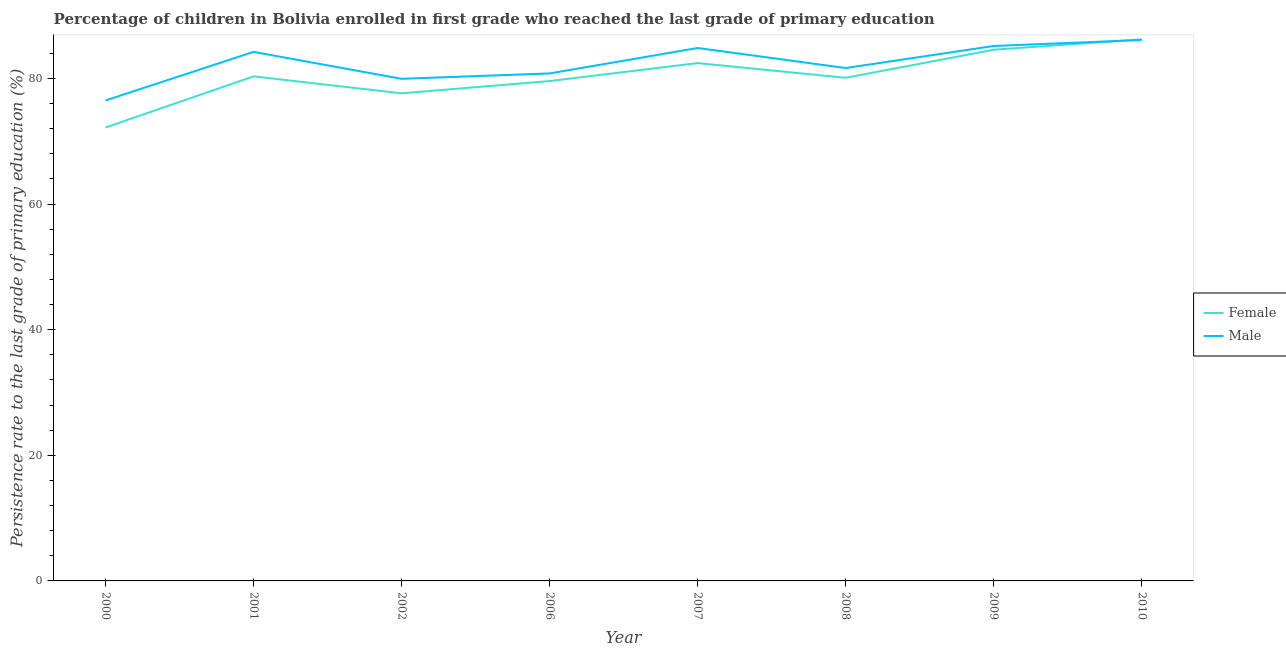How many different coloured lines are there?
Your answer should be compact. 2. What is the persistence rate of female students in 2010?
Your answer should be very brief. 86.24. Across all years, what is the maximum persistence rate of female students?
Offer a very short reply. 86.24. Across all years, what is the minimum persistence rate of female students?
Your answer should be very brief. 72.2. In which year was the persistence rate of male students maximum?
Your answer should be very brief. 2010. In which year was the persistence rate of male students minimum?
Give a very brief answer. 2000. What is the total persistence rate of female students in the graph?
Keep it short and to the point. 643.13. What is the difference between the persistence rate of male students in 2008 and that in 2009?
Offer a very short reply. -3.51. What is the difference between the persistence rate of male students in 2009 and the persistence rate of female students in 2006?
Ensure brevity in your answer.  5.59. What is the average persistence rate of male students per year?
Provide a succinct answer. 82.41. In the year 2001, what is the difference between the persistence rate of male students and persistence rate of female students?
Offer a very short reply. 3.9. What is the ratio of the persistence rate of male students in 2000 to that in 2006?
Your answer should be very brief. 0.95. Is the persistence rate of male students in 2009 less than that in 2010?
Your response must be concise. Yes. Is the difference between the persistence rate of female students in 2006 and 2010 greater than the difference between the persistence rate of male students in 2006 and 2010?
Offer a terse response. No. What is the difference between the highest and the second highest persistence rate of female students?
Your answer should be compact. 1.66. What is the difference between the highest and the lowest persistence rate of female students?
Offer a very short reply. 14.04. Does the persistence rate of male students monotonically increase over the years?
Your answer should be very brief. No. Is the persistence rate of male students strictly less than the persistence rate of female students over the years?
Offer a very short reply. No. How many lines are there?
Provide a short and direct response. 2. What is the difference between two consecutive major ticks on the Y-axis?
Give a very brief answer. 20. Does the graph contain any zero values?
Make the answer very short. No. Does the graph contain grids?
Offer a very short reply. No. Where does the legend appear in the graph?
Provide a short and direct response. Center right. How many legend labels are there?
Your answer should be compact. 2. How are the legend labels stacked?
Provide a short and direct response. Vertical. What is the title of the graph?
Give a very brief answer. Percentage of children in Bolivia enrolled in first grade who reached the last grade of primary education. Does "Rural" appear as one of the legend labels in the graph?
Keep it short and to the point. No. What is the label or title of the Y-axis?
Ensure brevity in your answer.  Persistence rate to the last grade of primary education (%). What is the Persistence rate to the last grade of primary education (%) in Female in 2000?
Make the answer very short. 72.2. What is the Persistence rate to the last grade of primary education (%) of Male in 2000?
Ensure brevity in your answer.  76.5. What is the Persistence rate to the last grade of primary education (%) of Female in 2001?
Your answer should be compact. 80.34. What is the Persistence rate to the last grade of primary education (%) of Male in 2001?
Give a very brief answer. 84.23. What is the Persistence rate to the last grade of primary education (%) in Female in 2002?
Provide a short and direct response. 77.64. What is the Persistence rate to the last grade of primary education (%) in Male in 2002?
Provide a short and direct response. 79.95. What is the Persistence rate to the last grade of primary education (%) of Female in 2006?
Keep it short and to the point. 79.59. What is the Persistence rate to the last grade of primary education (%) in Male in 2006?
Your answer should be very brief. 80.8. What is the Persistence rate to the last grade of primary education (%) of Female in 2007?
Your answer should be compact. 82.45. What is the Persistence rate to the last grade of primary education (%) of Male in 2007?
Your answer should be compact. 84.85. What is the Persistence rate to the last grade of primary education (%) in Female in 2008?
Provide a succinct answer. 80.11. What is the Persistence rate to the last grade of primary education (%) in Male in 2008?
Provide a short and direct response. 81.66. What is the Persistence rate to the last grade of primary education (%) in Female in 2009?
Make the answer very short. 84.58. What is the Persistence rate to the last grade of primary education (%) in Male in 2009?
Your answer should be compact. 85.17. What is the Persistence rate to the last grade of primary education (%) in Female in 2010?
Your answer should be compact. 86.24. What is the Persistence rate to the last grade of primary education (%) of Male in 2010?
Ensure brevity in your answer.  86.13. Across all years, what is the maximum Persistence rate to the last grade of primary education (%) of Female?
Make the answer very short. 86.24. Across all years, what is the maximum Persistence rate to the last grade of primary education (%) of Male?
Your answer should be very brief. 86.13. Across all years, what is the minimum Persistence rate to the last grade of primary education (%) of Female?
Your answer should be compact. 72.2. Across all years, what is the minimum Persistence rate to the last grade of primary education (%) in Male?
Ensure brevity in your answer.  76.5. What is the total Persistence rate to the last grade of primary education (%) of Female in the graph?
Provide a short and direct response. 643.13. What is the total Persistence rate to the last grade of primary education (%) of Male in the graph?
Provide a short and direct response. 659.3. What is the difference between the Persistence rate to the last grade of primary education (%) of Female in 2000 and that in 2001?
Your answer should be compact. -8.14. What is the difference between the Persistence rate to the last grade of primary education (%) in Male in 2000 and that in 2001?
Provide a succinct answer. -7.73. What is the difference between the Persistence rate to the last grade of primary education (%) of Female in 2000 and that in 2002?
Offer a terse response. -5.44. What is the difference between the Persistence rate to the last grade of primary education (%) in Male in 2000 and that in 2002?
Provide a succinct answer. -3.45. What is the difference between the Persistence rate to the last grade of primary education (%) in Female in 2000 and that in 2006?
Ensure brevity in your answer.  -7.39. What is the difference between the Persistence rate to the last grade of primary education (%) of Male in 2000 and that in 2006?
Your answer should be compact. -4.3. What is the difference between the Persistence rate to the last grade of primary education (%) of Female in 2000 and that in 2007?
Ensure brevity in your answer.  -10.25. What is the difference between the Persistence rate to the last grade of primary education (%) in Male in 2000 and that in 2007?
Provide a short and direct response. -8.35. What is the difference between the Persistence rate to the last grade of primary education (%) of Female in 2000 and that in 2008?
Give a very brief answer. -7.91. What is the difference between the Persistence rate to the last grade of primary education (%) in Male in 2000 and that in 2008?
Offer a terse response. -5.16. What is the difference between the Persistence rate to the last grade of primary education (%) in Female in 2000 and that in 2009?
Offer a very short reply. -12.38. What is the difference between the Persistence rate to the last grade of primary education (%) in Male in 2000 and that in 2009?
Provide a short and direct response. -8.67. What is the difference between the Persistence rate to the last grade of primary education (%) of Female in 2000 and that in 2010?
Keep it short and to the point. -14.04. What is the difference between the Persistence rate to the last grade of primary education (%) in Male in 2000 and that in 2010?
Offer a terse response. -9.63. What is the difference between the Persistence rate to the last grade of primary education (%) of Female in 2001 and that in 2002?
Give a very brief answer. 2.7. What is the difference between the Persistence rate to the last grade of primary education (%) of Male in 2001 and that in 2002?
Offer a very short reply. 4.29. What is the difference between the Persistence rate to the last grade of primary education (%) in Female in 2001 and that in 2006?
Provide a short and direct response. 0.75. What is the difference between the Persistence rate to the last grade of primary education (%) in Male in 2001 and that in 2006?
Ensure brevity in your answer.  3.43. What is the difference between the Persistence rate to the last grade of primary education (%) of Female in 2001 and that in 2007?
Ensure brevity in your answer.  -2.11. What is the difference between the Persistence rate to the last grade of primary education (%) of Male in 2001 and that in 2007?
Keep it short and to the point. -0.62. What is the difference between the Persistence rate to the last grade of primary education (%) in Female in 2001 and that in 2008?
Your response must be concise. 0.23. What is the difference between the Persistence rate to the last grade of primary education (%) of Male in 2001 and that in 2008?
Provide a short and direct response. 2.57. What is the difference between the Persistence rate to the last grade of primary education (%) in Female in 2001 and that in 2009?
Give a very brief answer. -4.24. What is the difference between the Persistence rate to the last grade of primary education (%) in Male in 2001 and that in 2009?
Provide a short and direct response. -0.94. What is the difference between the Persistence rate to the last grade of primary education (%) in Female in 2001 and that in 2010?
Offer a very short reply. -5.9. What is the difference between the Persistence rate to the last grade of primary education (%) in Male in 2001 and that in 2010?
Offer a very short reply. -1.9. What is the difference between the Persistence rate to the last grade of primary education (%) in Female in 2002 and that in 2006?
Keep it short and to the point. -1.95. What is the difference between the Persistence rate to the last grade of primary education (%) of Male in 2002 and that in 2006?
Ensure brevity in your answer.  -0.85. What is the difference between the Persistence rate to the last grade of primary education (%) of Female in 2002 and that in 2007?
Your answer should be compact. -4.81. What is the difference between the Persistence rate to the last grade of primary education (%) of Male in 2002 and that in 2007?
Keep it short and to the point. -4.91. What is the difference between the Persistence rate to the last grade of primary education (%) of Female in 2002 and that in 2008?
Your answer should be very brief. -2.47. What is the difference between the Persistence rate to the last grade of primary education (%) in Male in 2002 and that in 2008?
Offer a terse response. -1.72. What is the difference between the Persistence rate to the last grade of primary education (%) of Female in 2002 and that in 2009?
Your response must be concise. -6.94. What is the difference between the Persistence rate to the last grade of primary education (%) of Male in 2002 and that in 2009?
Your response must be concise. -5.23. What is the difference between the Persistence rate to the last grade of primary education (%) of Female in 2002 and that in 2010?
Offer a terse response. -8.6. What is the difference between the Persistence rate to the last grade of primary education (%) in Male in 2002 and that in 2010?
Provide a succinct answer. -6.18. What is the difference between the Persistence rate to the last grade of primary education (%) in Female in 2006 and that in 2007?
Make the answer very short. -2.86. What is the difference between the Persistence rate to the last grade of primary education (%) of Male in 2006 and that in 2007?
Keep it short and to the point. -4.05. What is the difference between the Persistence rate to the last grade of primary education (%) of Female in 2006 and that in 2008?
Offer a very short reply. -0.52. What is the difference between the Persistence rate to the last grade of primary education (%) in Male in 2006 and that in 2008?
Offer a terse response. -0.86. What is the difference between the Persistence rate to the last grade of primary education (%) in Female in 2006 and that in 2009?
Provide a short and direct response. -4.99. What is the difference between the Persistence rate to the last grade of primary education (%) in Male in 2006 and that in 2009?
Ensure brevity in your answer.  -4.37. What is the difference between the Persistence rate to the last grade of primary education (%) of Female in 2006 and that in 2010?
Your answer should be very brief. -6.65. What is the difference between the Persistence rate to the last grade of primary education (%) of Male in 2006 and that in 2010?
Keep it short and to the point. -5.33. What is the difference between the Persistence rate to the last grade of primary education (%) of Female in 2007 and that in 2008?
Offer a terse response. 2.34. What is the difference between the Persistence rate to the last grade of primary education (%) in Male in 2007 and that in 2008?
Provide a succinct answer. 3.19. What is the difference between the Persistence rate to the last grade of primary education (%) in Female in 2007 and that in 2009?
Ensure brevity in your answer.  -2.13. What is the difference between the Persistence rate to the last grade of primary education (%) of Male in 2007 and that in 2009?
Offer a terse response. -0.32. What is the difference between the Persistence rate to the last grade of primary education (%) in Female in 2007 and that in 2010?
Offer a very short reply. -3.79. What is the difference between the Persistence rate to the last grade of primary education (%) in Male in 2007 and that in 2010?
Your answer should be very brief. -1.28. What is the difference between the Persistence rate to the last grade of primary education (%) of Female in 2008 and that in 2009?
Ensure brevity in your answer.  -4.47. What is the difference between the Persistence rate to the last grade of primary education (%) of Male in 2008 and that in 2009?
Give a very brief answer. -3.51. What is the difference between the Persistence rate to the last grade of primary education (%) in Female in 2008 and that in 2010?
Make the answer very short. -6.13. What is the difference between the Persistence rate to the last grade of primary education (%) of Male in 2008 and that in 2010?
Provide a short and direct response. -4.47. What is the difference between the Persistence rate to the last grade of primary education (%) of Female in 2009 and that in 2010?
Your answer should be very brief. -1.66. What is the difference between the Persistence rate to the last grade of primary education (%) in Male in 2009 and that in 2010?
Your response must be concise. -0.96. What is the difference between the Persistence rate to the last grade of primary education (%) of Female in 2000 and the Persistence rate to the last grade of primary education (%) of Male in 2001?
Make the answer very short. -12.04. What is the difference between the Persistence rate to the last grade of primary education (%) in Female in 2000 and the Persistence rate to the last grade of primary education (%) in Male in 2002?
Give a very brief answer. -7.75. What is the difference between the Persistence rate to the last grade of primary education (%) in Female in 2000 and the Persistence rate to the last grade of primary education (%) in Male in 2006?
Offer a terse response. -8.61. What is the difference between the Persistence rate to the last grade of primary education (%) of Female in 2000 and the Persistence rate to the last grade of primary education (%) of Male in 2007?
Your response must be concise. -12.66. What is the difference between the Persistence rate to the last grade of primary education (%) of Female in 2000 and the Persistence rate to the last grade of primary education (%) of Male in 2008?
Make the answer very short. -9.47. What is the difference between the Persistence rate to the last grade of primary education (%) in Female in 2000 and the Persistence rate to the last grade of primary education (%) in Male in 2009?
Your answer should be compact. -12.98. What is the difference between the Persistence rate to the last grade of primary education (%) in Female in 2000 and the Persistence rate to the last grade of primary education (%) in Male in 2010?
Offer a terse response. -13.93. What is the difference between the Persistence rate to the last grade of primary education (%) of Female in 2001 and the Persistence rate to the last grade of primary education (%) of Male in 2002?
Your answer should be compact. 0.39. What is the difference between the Persistence rate to the last grade of primary education (%) in Female in 2001 and the Persistence rate to the last grade of primary education (%) in Male in 2006?
Your answer should be compact. -0.47. What is the difference between the Persistence rate to the last grade of primary education (%) in Female in 2001 and the Persistence rate to the last grade of primary education (%) in Male in 2007?
Provide a succinct answer. -4.52. What is the difference between the Persistence rate to the last grade of primary education (%) in Female in 2001 and the Persistence rate to the last grade of primary education (%) in Male in 2008?
Keep it short and to the point. -1.33. What is the difference between the Persistence rate to the last grade of primary education (%) in Female in 2001 and the Persistence rate to the last grade of primary education (%) in Male in 2009?
Keep it short and to the point. -4.84. What is the difference between the Persistence rate to the last grade of primary education (%) of Female in 2001 and the Persistence rate to the last grade of primary education (%) of Male in 2010?
Your answer should be very brief. -5.79. What is the difference between the Persistence rate to the last grade of primary education (%) in Female in 2002 and the Persistence rate to the last grade of primary education (%) in Male in 2006?
Your answer should be compact. -3.17. What is the difference between the Persistence rate to the last grade of primary education (%) in Female in 2002 and the Persistence rate to the last grade of primary education (%) in Male in 2007?
Provide a succinct answer. -7.22. What is the difference between the Persistence rate to the last grade of primary education (%) in Female in 2002 and the Persistence rate to the last grade of primary education (%) in Male in 2008?
Provide a short and direct response. -4.03. What is the difference between the Persistence rate to the last grade of primary education (%) of Female in 2002 and the Persistence rate to the last grade of primary education (%) of Male in 2009?
Offer a terse response. -7.54. What is the difference between the Persistence rate to the last grade of primary education (%) of Female in 2002 and the Persistence rate to the last grade of primary education (%) of Male in 2010?
Your answer should be compact. -8.49. What is the difference between the Persistence rate to the last grade of primary education (%) of Female in 2006 and the Persistence rate to the last grade of primary education (%) of Male in 2007?
Offer a very short reply. -5.27. What is the difference between the Persistence rate to the last grade of primary education (%) in Female in 2006 and the Persistence rate to the last grade of primary education (%) in Male in 2008?
Provide a succinct answer. -2.08. What is the difference between the Persistence rate to the last grade of primary education (%) in Female in 2006 and the Persistence rate to the last grade of primary education (%) in Male in 2009?
Give a very brief answer. -5.59. What is the difference between the Persistence rate to the last grade of primary education (%) in Female in 2006 and the Persistence rate to the last grade of primary education (%) in Male in 2010?
Give a very brief answer. -6.54. What is the difference between the Persistence rate to the last grade of primary education (%) of Female in 2007 and the Persistence rate to the last grade of primary education (%) of Male in 2008?
Provide a succinct answer. 0.79. What is the difference between the Persistence rate to the last grade of primary education (%) of Female in 2007 and the Persistence rate to the last grade of primary education (%) of Male in 2009?
Ensure brevity in your answer.  -2.72. What is the difference between the Persistence rate to the last grade of primary education (%) of Female in 2007 and the Persistence rate to the last grade of primary education (%) of Male in 2010?
Offer a terse response. -3.68. What is the difference between the Persistence rate to the last grade of primary education (%) in Female in 2008 and the Persistence rate to the last grade of primary education (%) in Male in 2009?
Provide a short and direct response. -5.07. What is the difference between the Persistence rate to the last grade of primary education (%) in Female in 2008 and the Persistence rate to the last grade of primary education (%) in Male in 2010?
Offer a terse response. -6.02. What is the difference between the Persistence rate to the last grade of primary education (%) in Female in 2009 and the Persistence rate to the last grade of primary education (%) in Male in 2010?
Offer a very short reply. -1.55. What is the average Persistence rate to the last grade of primary education (%) of Female per year?
Your response must be concise. 80.39. What is the average Persistence rate to the last grade of primary education (%) of Male per year?
Your response must be concise. 82.41. In the year 2000, what is the difference between the Persistence rate to the last grade of primary education (%) of Female and Persistence rate to the last grade of primary education (%) of Male?
Offer a very short reply. -4.3. In the year 2001, what is the difference between the Persistence rate to the last grade of primary education (%) of Female and Persistence rate to the last grade of primary education (%) of Male?
Your answer should be compact. -3.9. In the year 2002, what is the difference between the Persistence rate to the last grade of primary education (%) in Female and Persistence rate to the last grade of primary education (%) in Male?
Offer a very short reply. -2.31. In the year 2006, what is the difference between the Persistence rate to the last grade of primary education (%) of Female and Persistence rate to the last grade of primary education (%) of Male?
Offer a very short reply. -1.21. In the year 2007, what is the difference between the Persistence rate to the last grade of primary education (%) in Female and Persistence rate to the last grade of primary education (%) in Male?
Your response must be concise. -2.4. In the year 2008, what is the difference between the Persistence rate to the last grade of primary education (%) of Female and Persistence rate to the last grade of primary education (%) of Male?
Give a very brief answer. -1.56. In the year 2009, what is the difference between the Persistence rate to the last grade of primary education (%) of Female and Persistence rate to the last grade of primary education (%) of Male?
Give a very brief answer. -0.59. In the year 2010, what is the difference between the Persistence rate to the last grade of primary education (%) in Female and Persistence rate to the last grade of primary education (%) in Male?
Keep it short and to the point. 0.11. What is the ratio of the Persistence rate to the last grade of primary education (%) in Female in 2000 to that in 2001?
Make the answer very short. 0.9. What is the ratio of the Persistence rate to the last grade of primary education (%) of Male in 2000 to that in 2001?
Make the answer very short. 0.91. What is the ratio of the Persistence rate to the last grade of primary education (%) of Female in 2000 to that in 2002?
Offer a very short reply. 0.93. What is the ratio of the Persistence rate to the last grade of primary education (%) of Male in 2000 to that in 2002?
Provide a succinct answer. 0.96. What is the ratio of the Persistence rate to the last grade of primary education (%) in Female in 2000 to that in 2006?
Ensure brevity in your answer.  0.91. What is the ratio of the Persistence rate to the last grade of primary education (%) in Male in 2000 to that in 2006?
Ensure brevity in your answer.  0.95. What is the ratio of the Persistence rate to the last grade of primary education (%) in Female in 2000 to that in 2007?
Provide a succinct answer. 0.88. What is the ratio of the Persistence rate to the last grade of primary education (%) of Male in 2000 to that in 2007?
Your answer should be compact. 0.9. What is the ratio of the Persistence rate to the last grade of primary education (%) in Female in 2000 to that in 2008?
Your answer should be compact. 0.9. What is the ratio of the Persistence rate to the last grade of primary education (%) of Male in 2000 to that in 2008?
Your response must be concise. 0.94. What is the ratio of the Persistence rate to the last grade of primary education (%) in Female in 2000 to that in 2009?
Offer a very short reply. 0.85. What is the ratio of the Persistence rate to the last grade of primary education (%) of Male in 2000 to that in 2009?
Offer a very short reply. 0.9. What is the ratio of the Persistence rate to the last grade of primary education (%) of Female in 2000 to that in 2010?
Keep it short and to the point. 0.84. What is the ratio of the Persistence rate to the last grade of primary education (%) of Male in 2000 to that in 2010?
Give a very brief answer. 0.89. What is the ratio of the Persistence rate to the last grade of primary education (%) of Female in 2001 to that in 2002?
Give a very brief answer. 1.03. What is the ratio of the Persistence rate to the last grade of primary education (%) in Male in 2001 to that in 2002?
Keep it short and to the point. 1.05. What is the ratio of the Persistence rate to the last grade of primary education (%) of Female in 2001 to that in 2006?
Provide a succinct answer. 1.01. What is the ratio of the Persistence rate to the last grade of primary education (%) of Male in 2001 to that in 2006?
Make the answer very short. 1.04. What is the ratio of the Persistence rate to the last grade of primary education (%) in Female in 2001 to that in 2007?
Keep it short and to the point. 0.97. What is the ratio of the Persistence rate to the last grade of primary education (%) in Male in 2001 to that in 2007?
Provide a succinct answer. 0.99. What is the ratio of the Persistence rate to the last grade of primary education (%) in Male in 2001 to that in 2008?
Your answer should be very brief. 1.03. What is the ratio of the Persistence rate to the last grade of primary education (%) of Female in 2001 to that in 2009?
Keep it short and to the point. 0.95. What is the ratio of the Persistence rate to the last grade of primary education (%) in Male in 2001 to that in 2009?
Give a very brief answer. 0.99. What is the ratio of the Persistence rate to the last grade of primary education (%) of Female in 2001 to that in 2010?
Offer a very short reply. 0.93. What is the ratio of the Persistence rate to the last grade of primary education (%) of Female in 2002 to that in 2006?
Your answer should be very brief. 0.98. What is the ratio of the Persistence rate to the last grade of primary education (%) in Female in 2002 to that in 2007?
Provide a short and direct response. 0.94. What is the ratio of the Persistence rate to the last grade of primary education (%) in Male in 2002 to that in 2007?
Your answer should be compact. 0.94. What is the ratio of the Persistence rate to the last grade of primary education (%) of Female in 2002 to that in 2008?
Offer a very short reply. 0.97. What is the ratio of the Persistence rate to the last grade of primary education (%) of Male in 2002 to that in 2008?
Provide a succinct answer. 0.98. What is the ratio of the Persistence rate to the last grade of primary education (%) of Female in 2002 to that in 2009?
Provide a succinct answer. 0.92. What is the ratio of the Persistence rate to the last grade of primary education (%) of Male in 2002 to that in 2009?
Provide a succinct answer. 0.94. What is the ratio of the Persistence rate to the last grade of primary education (%) in Female in 2002 to that in 2010?
Your response must be concise. 0.9. What is the ratio of the Persistence rate to the last grade of primary education (%) in Male in 2002 to that in 2010?
Your answer should be very brief. 0.93. What is the ratio of the Persistence rate to the last grade of primary education (%) of Female in 2006 to that in 2007?
Provide a succinct answer. 0.97. What is the ratio of the Persistence rate to the last grade of primary education (%) of Male in 2006 to that in 2007?
Give a very brief answer. 0.95. What is the ratio of the Persistence rate to the last grade of primary education (%) in Female in 2006 to that in 2008?
Make the answer very short. 0.99. What is the ratio of the Persistence rate to the last grade of primary education (%) of Female in 2006 to that in 2009?
Offer a terse response. 0.94. What is the ratio of the Persistence rate to the last grade of primary education (%) of Male in 2006 to that in 2009?
Offer a terse response. 0.95. What is the ratio of the Persistence rate to the last grade of primary education (%) of Female in 2006 to that in 2010?
Provide a succinct answer. 0.92. What is the ratio of the Persistence rate to the last grade of primary education (%) of Male in 2006 to that in 2010?
Your answer should be compact. 0.94. What is the ratio of the Persistence rate to the last grade of primary education (%) in Female in 2007 to that in 2008?
Your answer should be compact. 1.03. What is the ratio of the Persistence rate to the last grade of primary education (%) in Male in 2007 to that in 2008?
Provide a succinct answer. 1.04. What is the ratio of the Persistence rate to the last grade of primary education (%) of Female in 2007 to that in 2009?
Your answer should be compact. 0.97. What is the ratio of the Persistence rate to the last grade of primary education (%) in Male in 2007 to that in 2009?
Your answer should be very brief. 1. What is the ratio of the Persistence rate to the last grade of primary education (%) of Female in 2007 to that in 2010?
Offer a very short reply. 0.96. What is the ratio of the Persistence rate to the last grade of primary education (%) in Male in 2007 to that in 2010?
Provide a succinct answer. 0.99. What is the ratio of the Persistence rate to the last grade of primary education (%) of Female in 2008 to that in 2009?
Keep it short and to the point. 0.95. What is the ratio of the Persistence rate to the last grade of primary education (%) in Male in 2008 to that in 2009?
Keep it short and to the point. 0.96. What is the ratio of the Persistence rate to the last grade of primary education (%) in Female in 2008 to that in 2010?
Offer a terse response. 0.93. What is the ratio of the Persistence rate to the last grade of primary education (%) of Male in 2008 to that in 2010?
Your answer should be very brief. 0.95. What is the ratio of the Persistence rate to the last grade of primary education (%) in Female in 2009 to that in 2010?
Offer a terse response. 0.98. What is the ratio of the Persistence rate to the last grade of primary education (%) of Male in 2009 to that in 2010?
Offer a very short reply. 0.99. What is the difference between the highest and the second highest Persistence rate to the last grade of primary education (%) in Female?
Offer a very short reply. 1.66. What is the difference between the highest and the second highest Persistence rate to the last grade of primary education (%) of Male?
Keep it short and to the point. 0.96. What is the difference between the highest and the lowest Persistence rate to the last grade of primary education (%) of Female?
Your answer should be very brief. 14.04. What is the difference between the highest and the lowest Persistence rate to the last grade of primary education (%) of Male?
Keep it short and to the point. 9.63. 